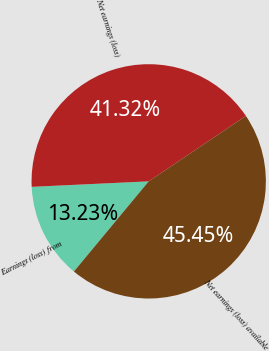Convert chart. <chart><loc_0><loc_0><loc_500><loc_500><pie_chart><fcel>Earnings (loss) from<fcel>Net earnings (loss)<fcel>Net earnings (loss) available<nl><fcel>13.23%<fcel>41.32%<fcel>45.45%<nl></chart> 